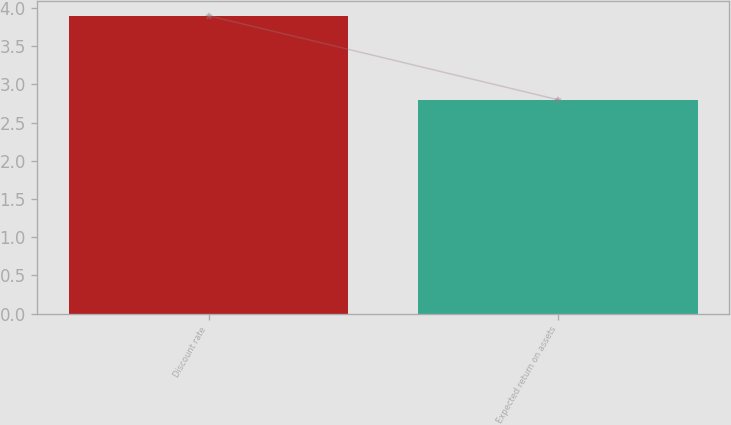Convert chart. <chart><loc_0><loc_0><loc_500><loc_500><bar_chart><fcel>Discount rate<fcel>Expected return on assets<nl><fcel>3.9<fcel>2.8<nl></chart> 